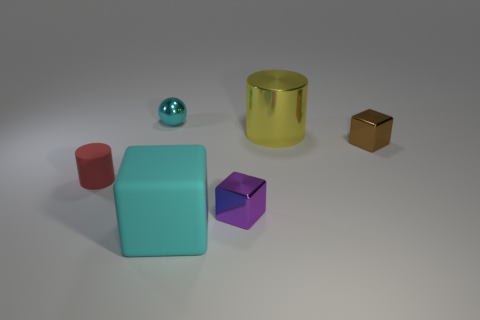Add 2 tiny green rubber blocks. How many objects exist? 8 Subtract all cylinders. How many objects are left? 4 Subtract all cyan rubber cubes. Subtract all shiny cylinders. How many objects are left? 4 Add 3 big yellow shiny things. How many big yellow shiny things are left? 4 Add 2 small cyan objects. How many small cyan objects exist? 3 Subtract 1 yellow cylinders. How many objects are left? 5 